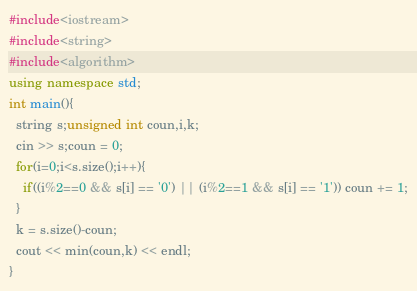Convert code to text. <code><loc_0><loc_0><loc_500><loc_500><_C++_>#include<iostream>
#include<string>
#include<algorithm>
using namespace std;
int main(){
  string s;unsigned int coun,i,k;
  cin >> s;coun = 0;
  for(i=0;i<s.size();i++){
    if((i%2==0 && s[i] == '0') || (i%2==1 && s[i] == '1')) coun += 1;
  }
  k = s.size()-coun;
  cout << min(coun,k) << endl;
}</code> 